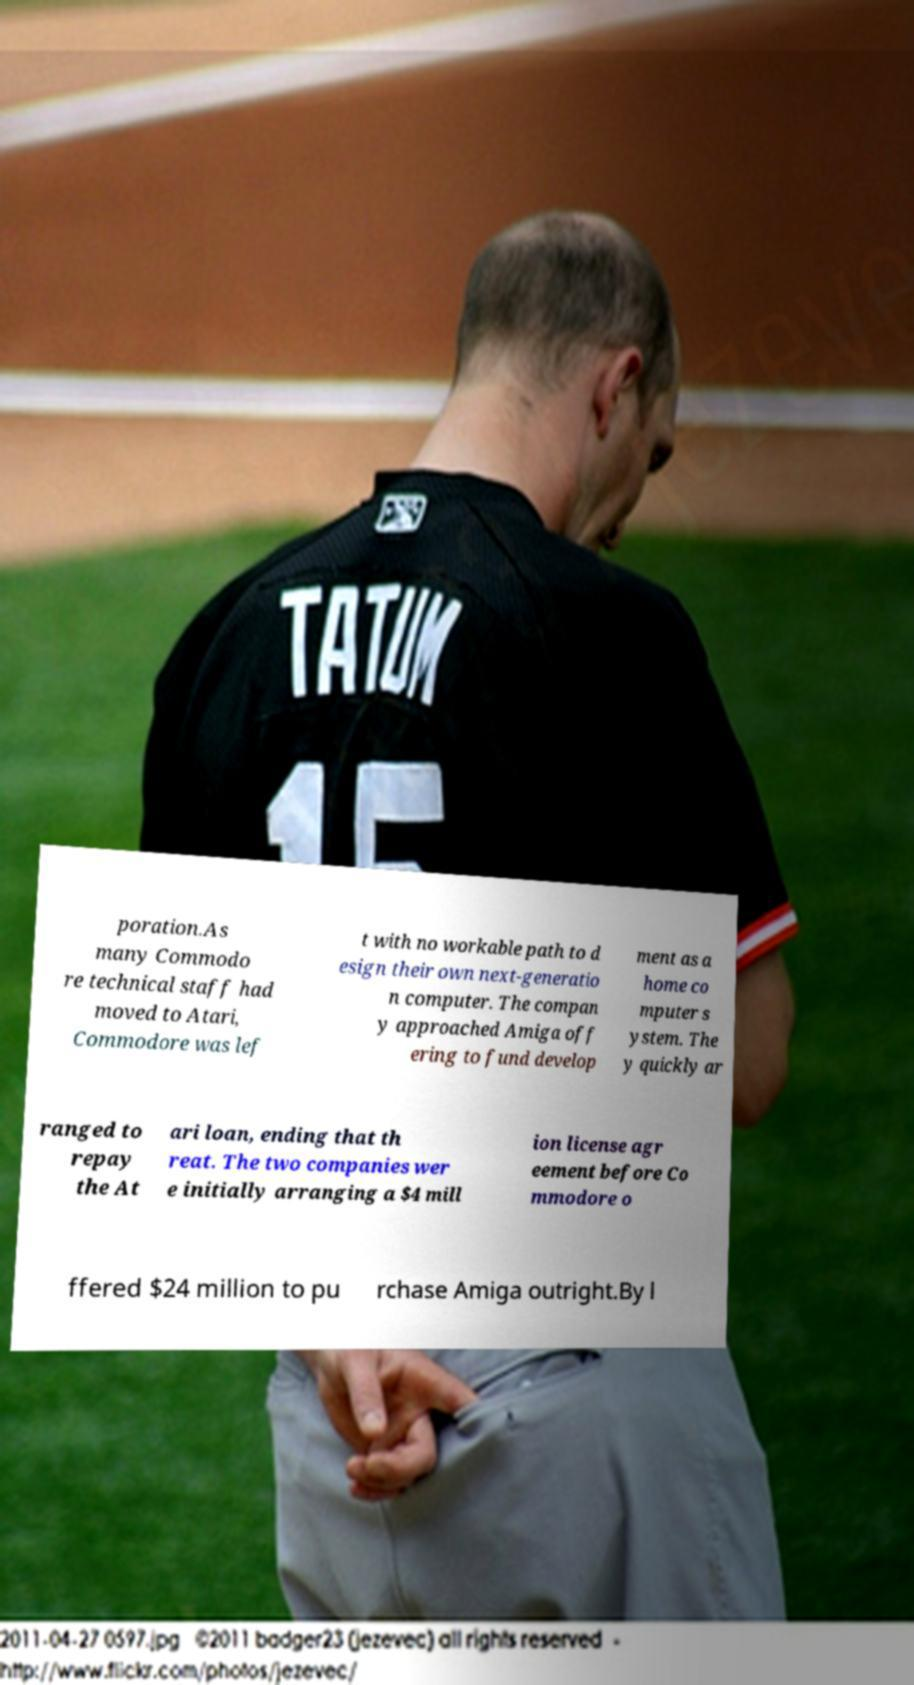Can you accurately transcribe the text from the provided image for me? poration.As many Commodo re technical staff had moved to Atari, Commodore was lef t with no workable path to d esign their own next-generatio n computer. The compan y approached Amiga off ering to fund develop ment as a home co mputer s ystem. The y quickly ar ranged to repay the At ari loan, ending that th reat. The two companies wer e initially arranging a $4 mill ion license agr eement before Co mmodore o ffered $24 million to pu rchase Amiga outright.By l 